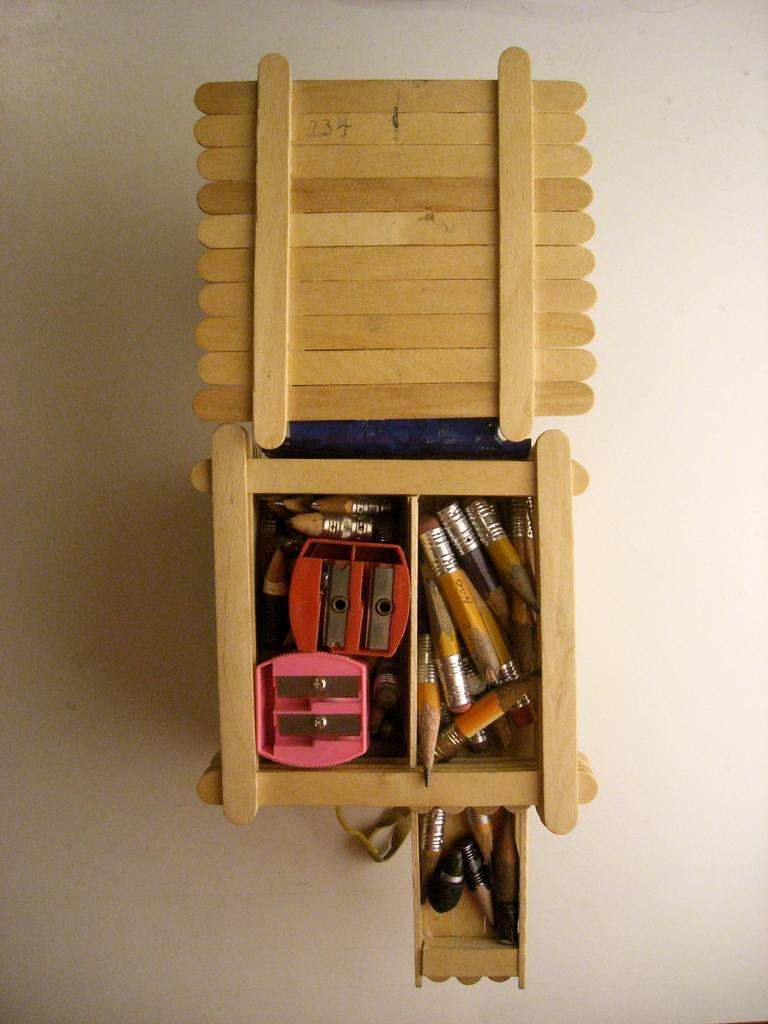What is the main object in the image made of? The main object in the image is a box made up of sticks. What is inside the box? There are accessories placed in the box. What is the color of the box? The box is in brown color. What is the surface the box is placed on? The box is placed on a cream color surface. How many pairs of jeans are visible in the image? There are no jeans present in the image. What type of blade can be seen cutting through the box? There is no blade present in the image; the box is made up of sticks and accessories are placed inside it. 